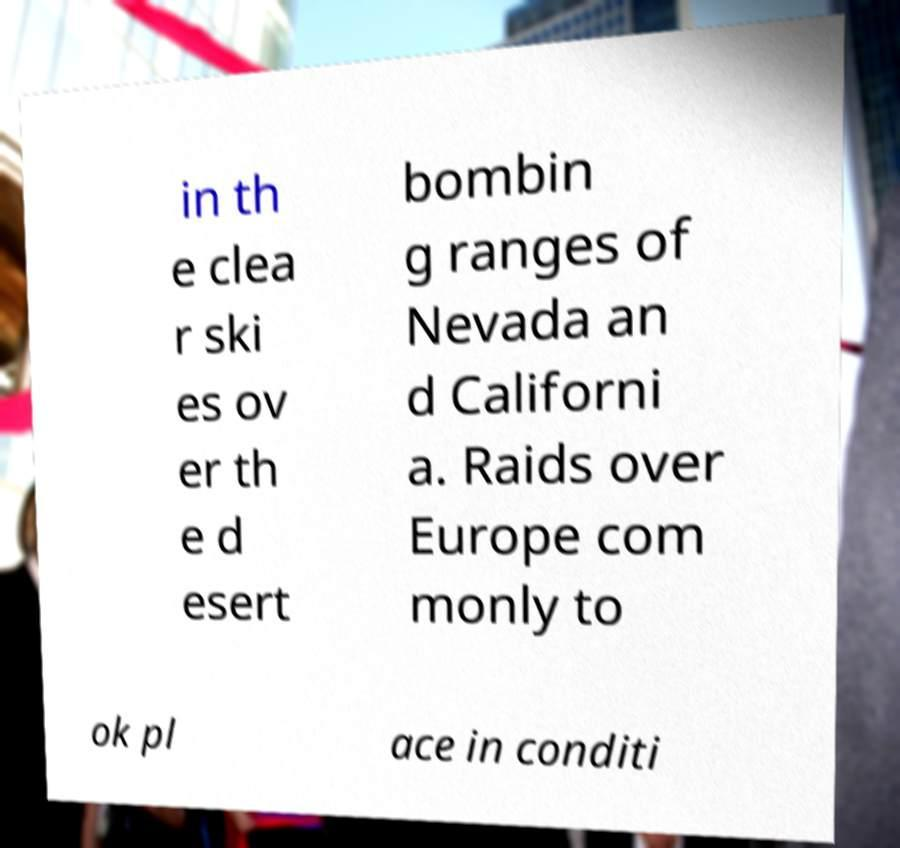What messages or text are displayed in this image? I need them in a readable, typed format. in th e clea r ski es ov er th e d esert bombin g ranges of Nevada an d Californi a. Raids over Europe com monly to ok pl ace in conditi 